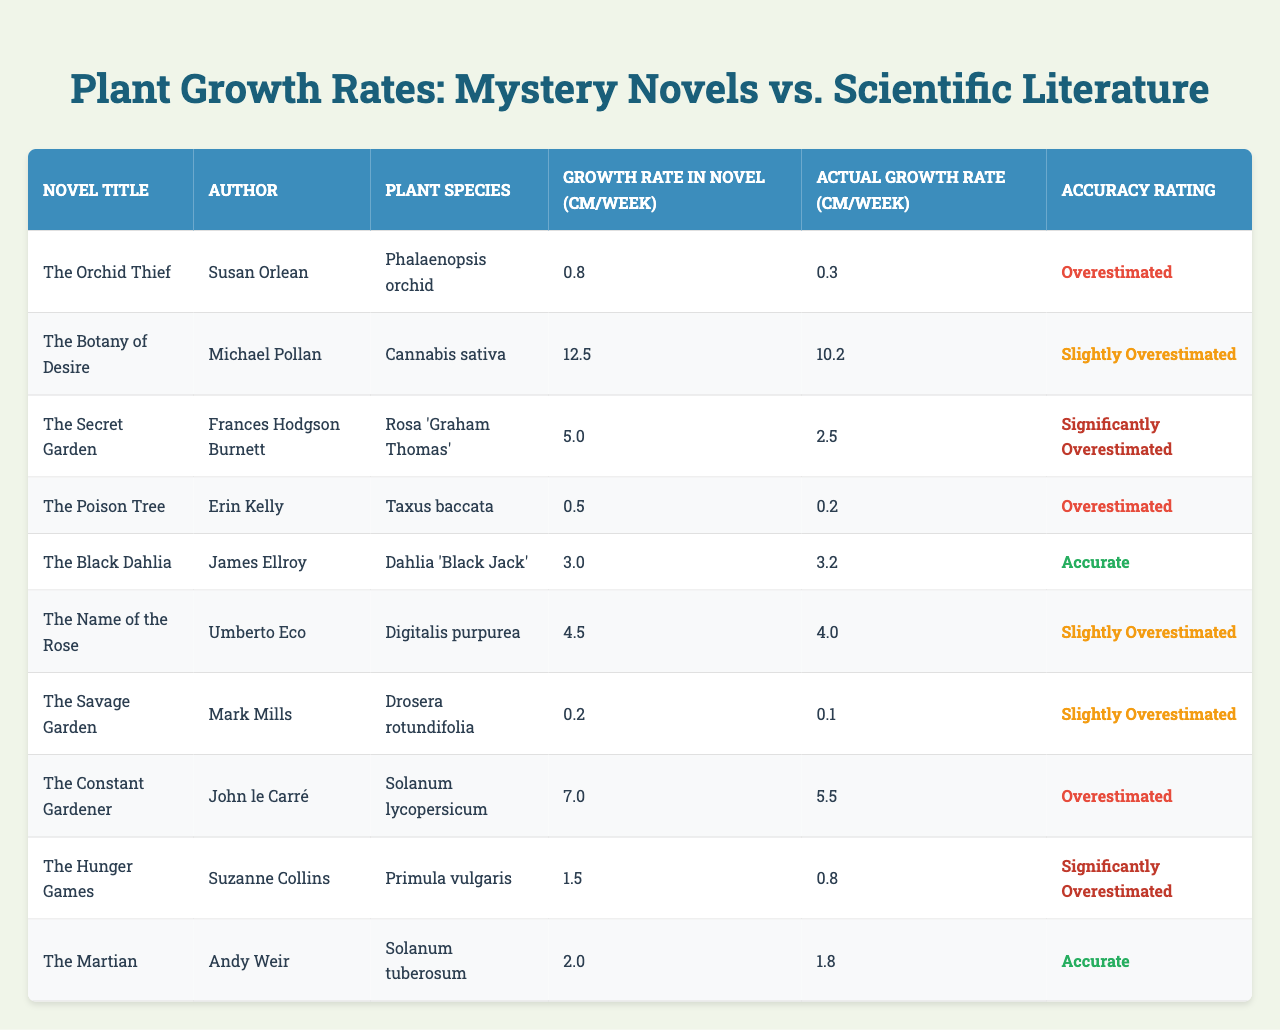What is the growth rate of the "Phalaenopsis orchid" as described in "The Orchid Thief"? In the table, the growth rate of the "Phalaenopsis orchid" in "The Orchid Thief" is listed as 0.8 cm/week.
Answer: 0.8 cm/week How many plant species have a growth rate that is accurately depicted in the novels? "The Black Dahlia" and "The Martian" are the two novels with accurate growth rate representations, as indicated in the accuracy rating column.
Answer: 2 Which novel has the largest difference between the growth rate in the novel and the actual growth rate? The novel "The Secret Garden" shows the largest difference: 5.0 cm/week (novel) - 2.5 cm/week (actual) = 2.5 cm/week.
Answer: "The Secret Garden" What is the total estimated overestimation (in cm/week) for the plants listed as overestimated? The total overestimation can be calculated by summing the differences for each novel rated as at least "Overestimated": (0.8 - 0.3) + (12.5 - 10.2) + (0.5 - 0.2) + (5.0 - 2.5) + (7.0 - 5.5) + (1.5 - 0.8) = 2.2 + 2.3 + 0.3 + 2.5 + 1.5 + 0.7 = 9.5 cm/week.
Answer: 9.5 cm/week What percentage of the total novels estimated plant growth are "Slightly Overestimated"? There are 3 novels rated as "Slightly Overestimated" out of a total of 10 novels. To find the percentage, (3/10) * 100 = 30%.
Answer: 30% Is there any novel that has both an accurate growth rate and a significantly overestimated growth rate? No, there are no novels that fall into both the "Accurate" and "Significantly Overestimated" categories; each novel is only categorized in one.
Answer: No Which author has a novel with the least growth rate described? "The Savage Garden" by Mark Mills has the least growth rate of 0.2 cm/week as shown in the table.
Answer: Mark Mills What is the average growth rate of all plants depicted in the table? To find the average, sum all the actual growth rates: (0.3 + 10.2 + 2.5 + 0.2 + 3.2 + 4.0 + 0.1 + 5.5 + 0.8 + 1.8) = 28.1 cm. Then divide by the number of novels (10): 28.1 / 10 = 2.81 cm/week.
Answer: 2.81 cm/week How many different authors are represented in the table? By examining the list of authors, it is clear that there are 10 distinct authors associated with the novels listed in the table.
Answer: 10 